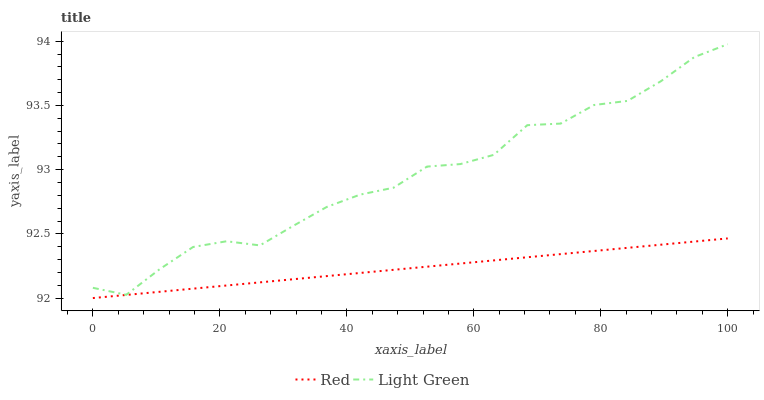Does Red have the minimum area under the curve?
Answer yes or no. Yes. Does Light Green have the maximum area under the curve?
Answer yes or no. Yes. Does Red have the maximum area under the curve?
Answer yes or no. No. Is Red the smoothest?
Answer yes or no. Yes. Is Light Green the roughest?
Answer yes or no. Yes. Is Red the roughest?
Answer yes or no. No. Does Red have the lowest value?
Answer yes or no. Yes. Does Light Green have the highest value?
Answer yes or no. Yes. Does Red have the highest value?
Answer yes or no. No. Is Red less than Light Green?
Answer yes or no. Yes. Is Light Green greater than Red?
Answer yes or no. Yes. Does Red intersect Light Green?
Answer yes or no. No. 